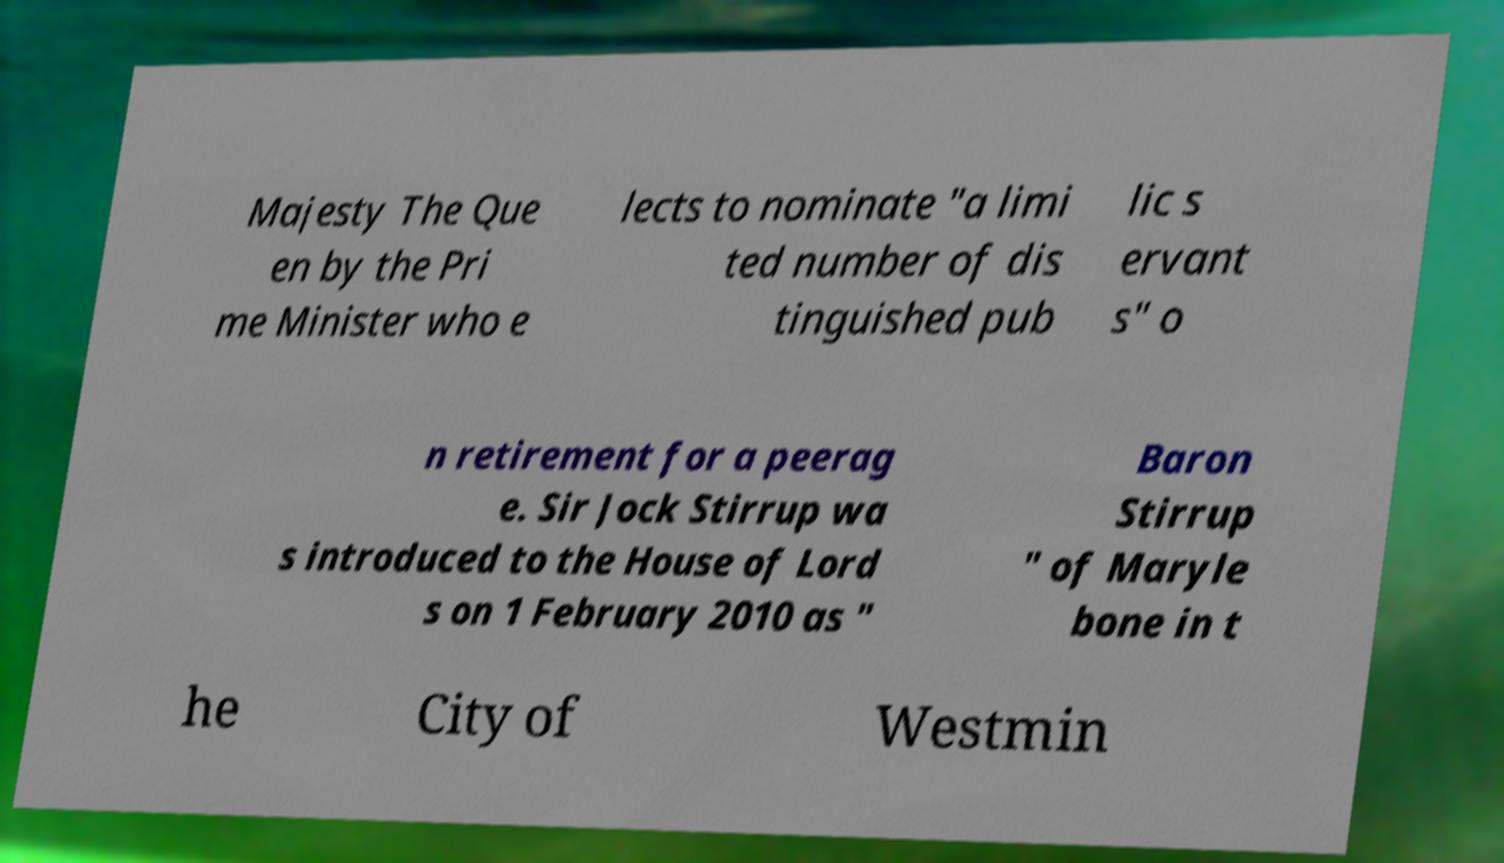There's text embedded in this image that I need extracted. Can you transcribe it verbatim? Majesty The Que en by the Pri me Minister who e lects to nominate "a limi ted number of dis tinguished pub lic s ervant s" o n retirement for a peerag e. Sir Jock Stirrup wa s introduced to the House of Lord s on 1 February 2010 as " Baron Stirrup " of Maryle bone in t he City of Westmin 